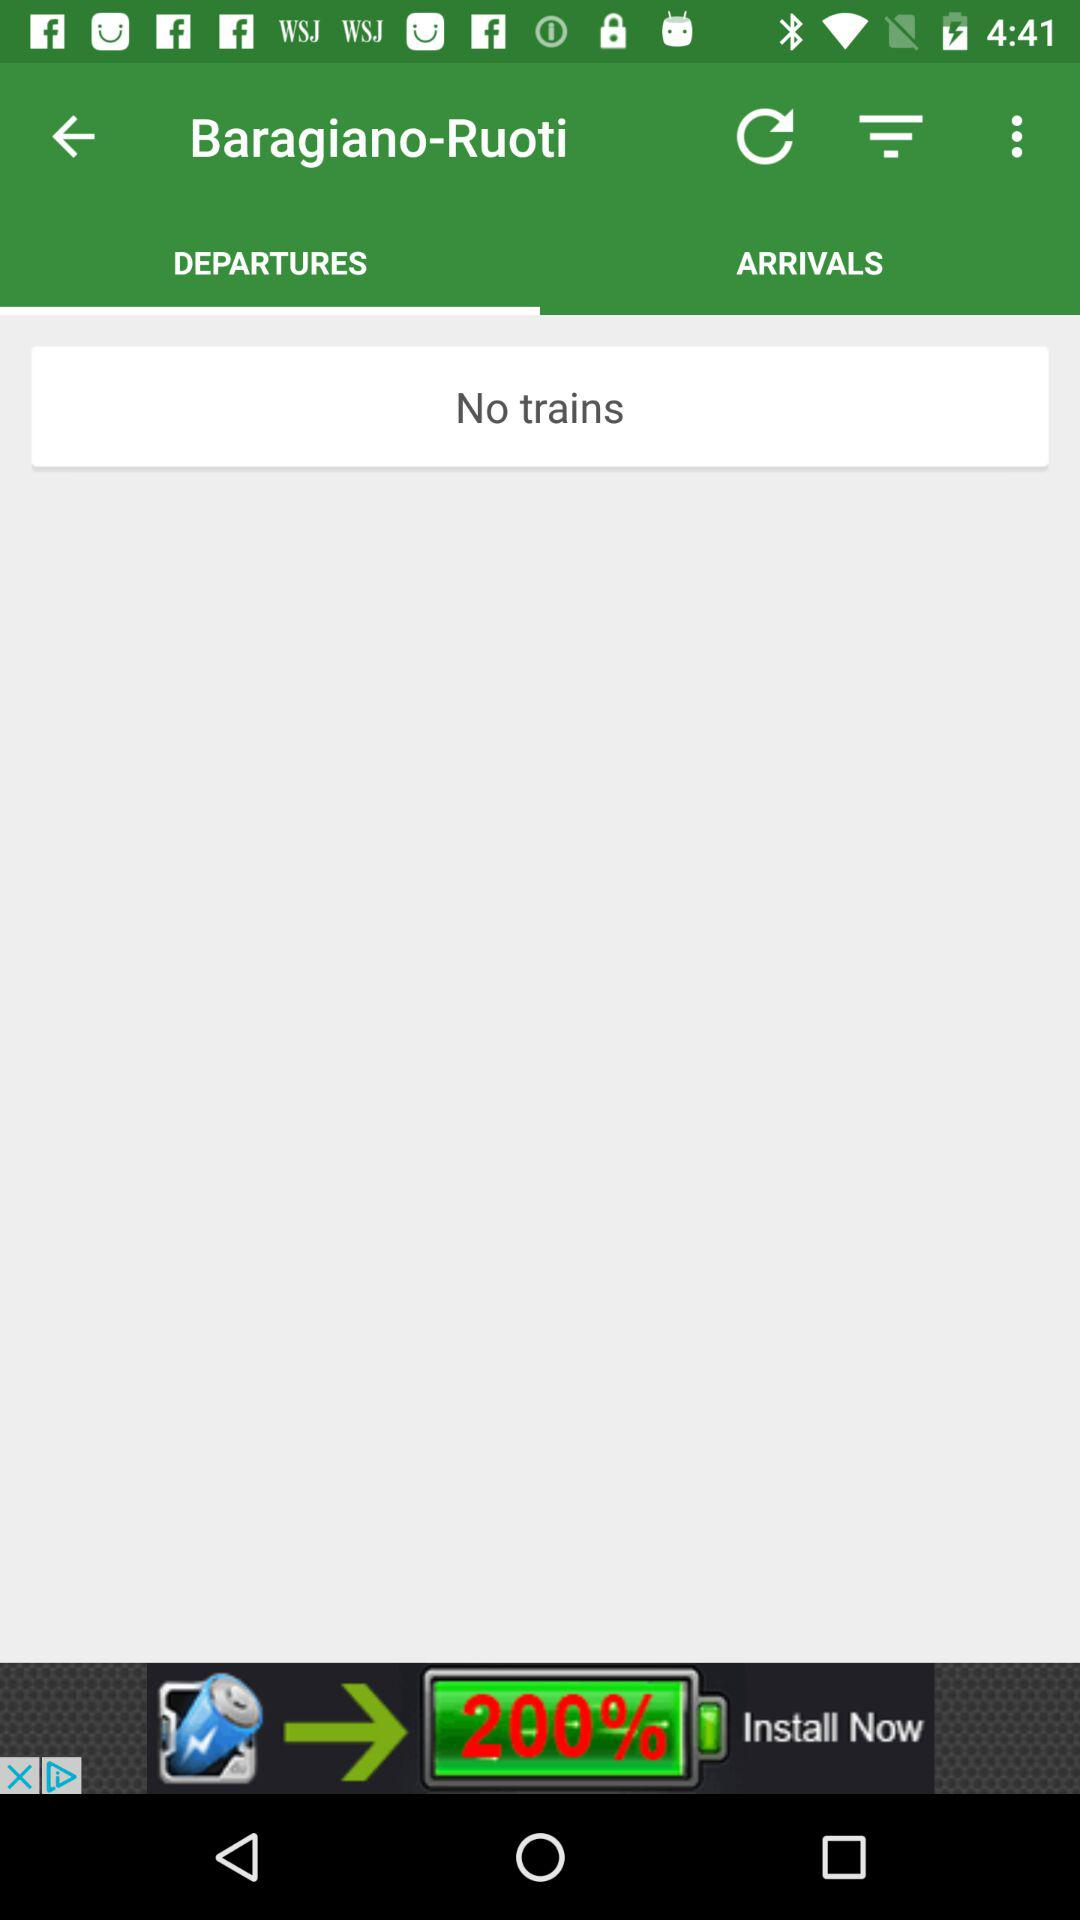What tab is selected? The selected tab is "DEPARTURES". 